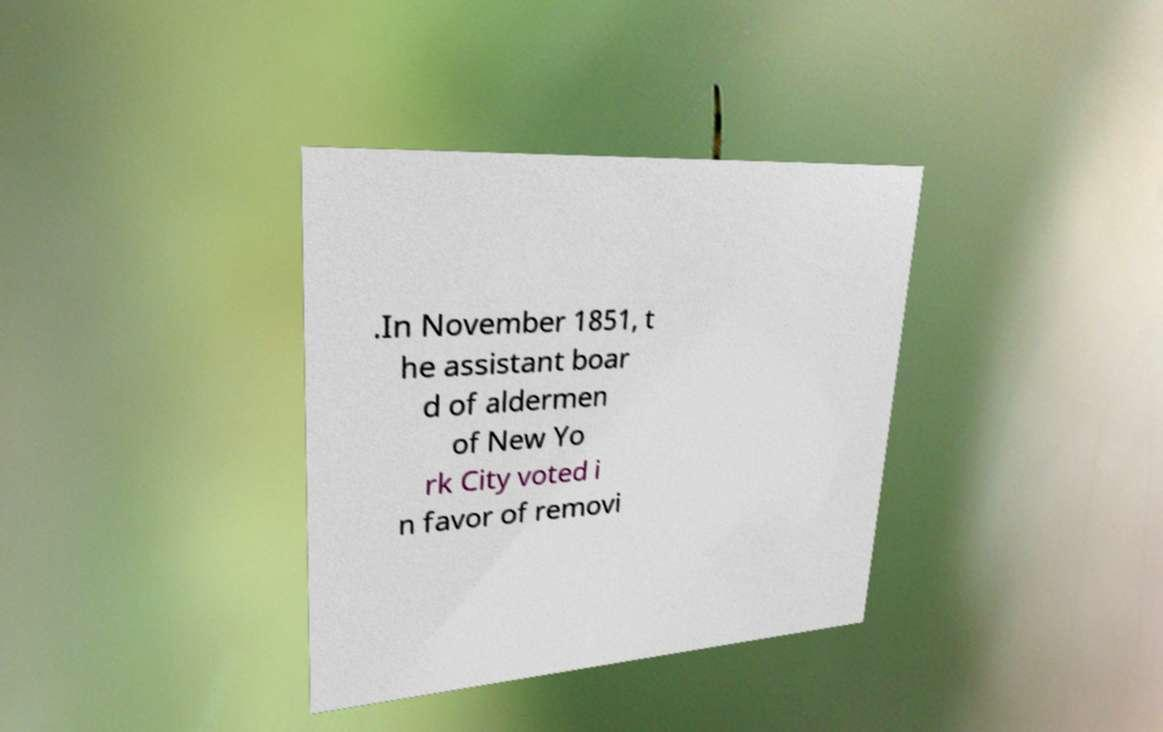Can you read and provide the text displayed in the image?This photo seems to have some interesting text. Can you extract and type it out for me? .In November 1851, t he assistant boar d of aldermen of New Yo rk City voted i n favor of removi 